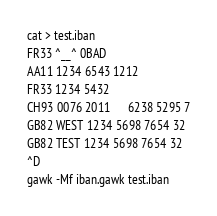Convert code to text. <code><loc_0><loc_0><loc_500><loc_500><_Awk_>cat > test.iban
FR33 ^__^ 0BAD
AA11 1234 6543 1212
FR33 1234 5432
CH93 0076 2011      6238 5295 7
GB82 WEST 1234 5698 7654 32
GB82 TEST 1234 5698 7654 32
^D
gawk -Mf iban.gawk test.iban
</code> 